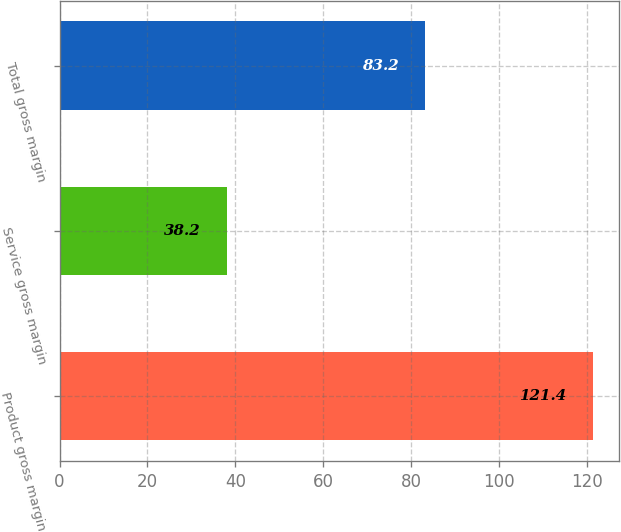<chart> <loc_0><loc_0><loc_500><loc_500><bar_chart><fcel>Product gross margin<fcel>Service gross margin<fcel>Total gross margin<nl><fcel>121.4<fcel>38.2<fcel>83.2<nl></chart> 